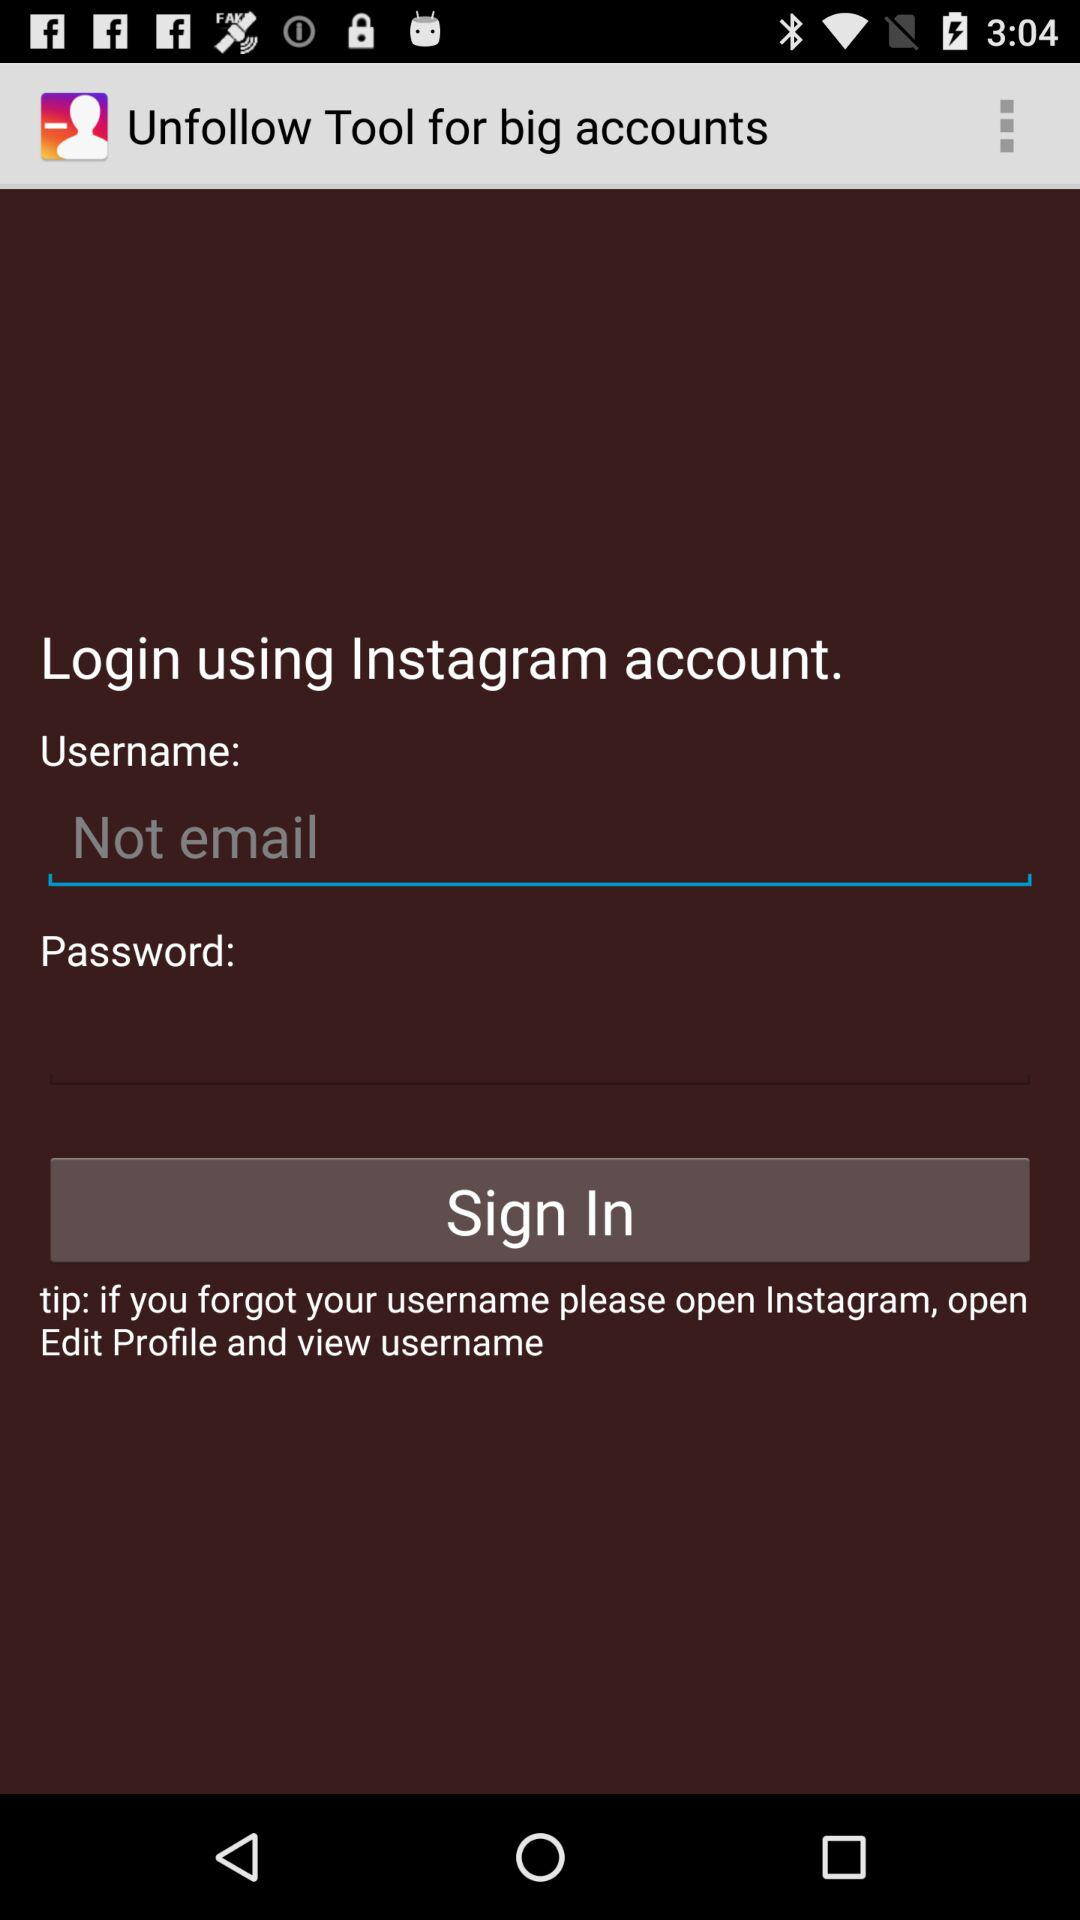What is the application name? The application names are "Unfollow Tool for big accounts" and "Instagram". 